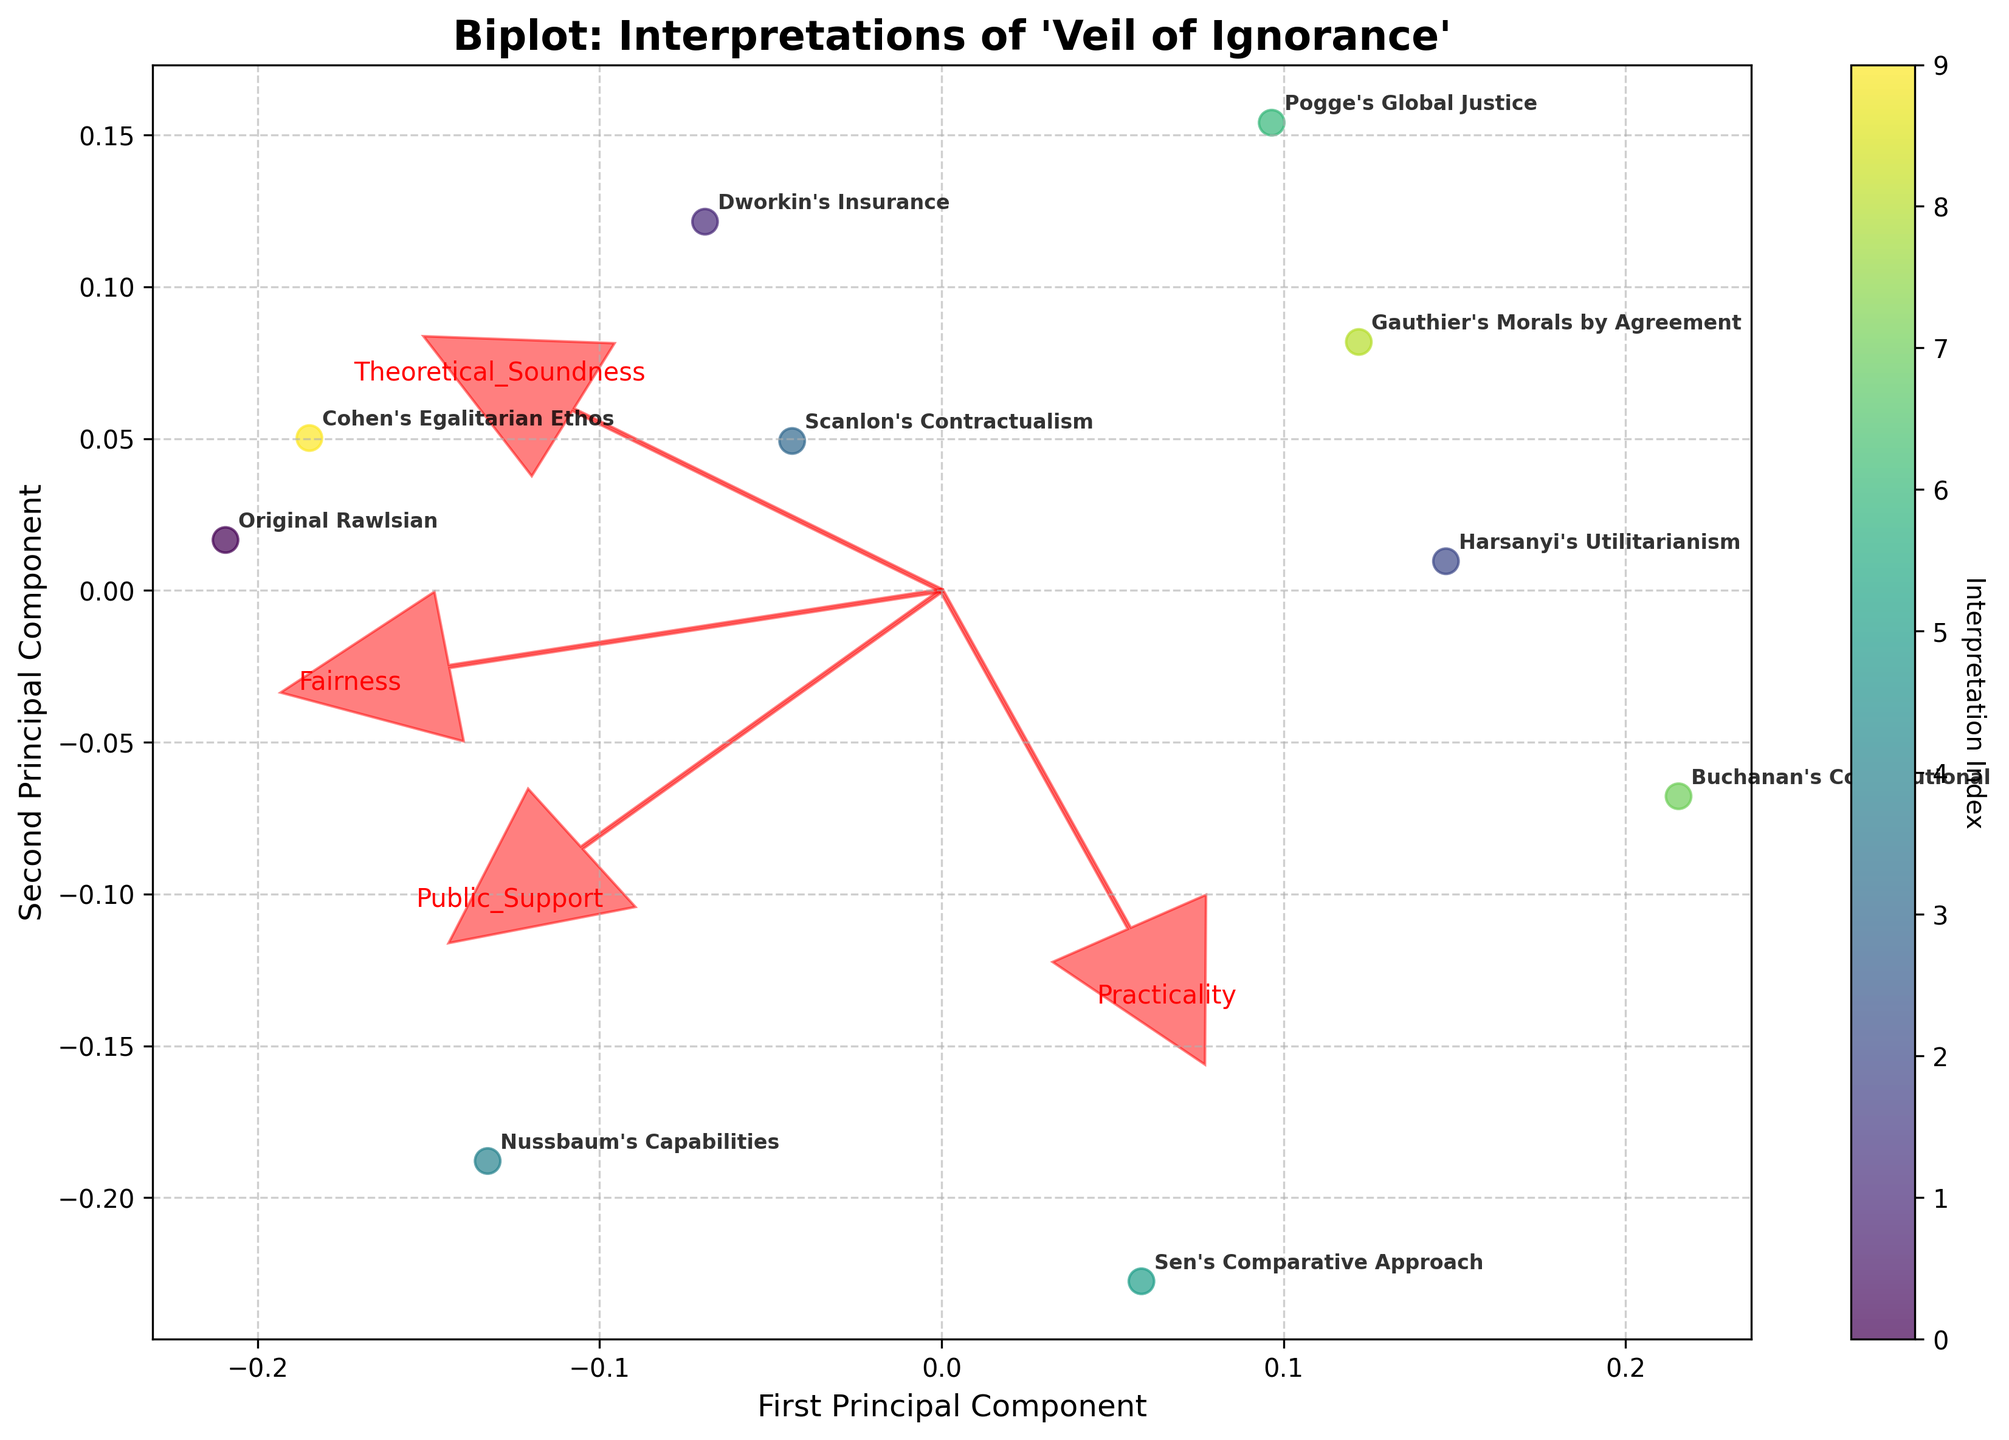What is the title of the figure? The title is usually positioned prominently at the top of the figure for immediate visibility. In this case, it is "Biplot: Interpretations of 'Veil of Ignorance'".
Answer: Biplot: Interpretations of 'Veil of Ignorance' How many interpretations of the "veil of ignorance" are plotted in the figure? By counting the labels corresponding to different interpretations on the plot, we can see that there are ten.
Answer: 10 Which interpretation appears closest to the origin (0, 0) on the Biplot? The points closer to the origin typically have coordinates near (0, 0). By observing the positions of the points, “Scanlon's Contractualism” appears the closest.
Answer: Scanlon's Contractualism Which variable vector has the longest arrow in the plot and likely explains the most variance? The length of a vector arrow represents the magnitude of the variable's contribution to the principal components. The variable with the longest arrow on the plot is Fairness.
Answer: Fairness Which interpretation has the highest value for fairness? Looking at the vectors and the spread of interpretation points along the direction of the fairness vector, we can see that “Original Rawlsian” and “Nussbaum's Capabilities” are the farthest in that direction.
Answer: Original Rawlsian and Nussbaum's Capabilities Does “Sen's Comparative Approach” rank higher in practicality or theoretical soundness based on the biplot direction? By observing the directions of the practicality and theoretical soundness vectors from the origin and the relative positioning of “Sen's Comparative Approach” with respect to these vectors, “Sen's Comparative Approach” is closer to the practicality vector. Hence, it ranks higher in practicality.
Answer: Practicality Which interpretation is furthest along the first principal component axis? The first principal component axis is the horizontal axis. The interpretation furthest along this axis can be identified by the most extreme value, which is "Nussbaum's Capabilities".
Answer: Nussbaum's Capabilities How is Cohen's Egalitarian Ethos positioned relative to Gauthier's Morals by Agreement on the plot? By comparing the relative positions of the two points “Cohen's Egalitarian Ethos” and “Gauthier's Morals by Agreement”, Cohen's Egalitarian Ethos is positioned higher and slightly to the right compared to Gauthier's Morals by Agreement.
Answer: Higher and slightly to the right What does the color gradient indicate on the points? According to the legend associated with the color bar, the color gradient represents the Interpretation Index, possibly a sequential position or categorization of the interpretations.
Answer: Interpretation Index Which two interpretations have similar coordinates on the biplot? Observing the closeness of points, “Scanlon's Contractualism” and “Dworkin's Insurance” are quite close to each other on the plot, indicating they share similar coordinates.
Answer: Scanlon's Contractualism and Dworkin's Insurance 